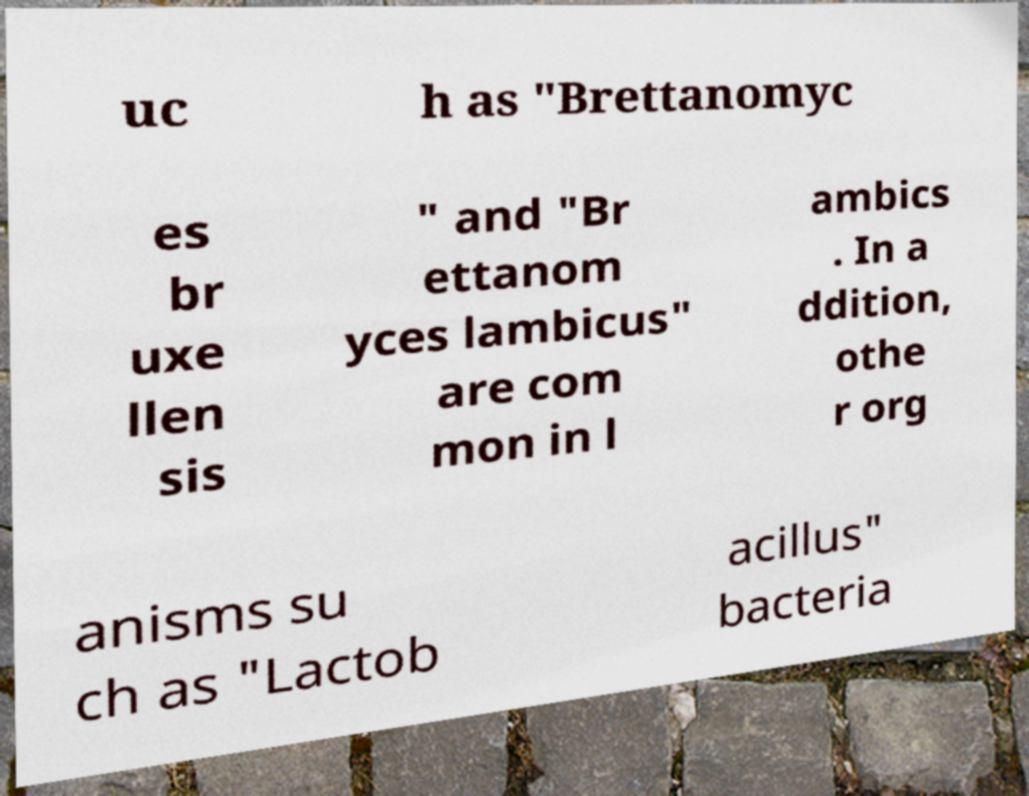For documentation purposes, I need the text within this image transcribed. Could you provide that? uc h as "Brettanomyc es br uxe llen sis " and "Br ettanom yces lambicus" are com mon in l ambics . In a ddition, othe r org anisms su ch as "Lactob acillus" bacteria 